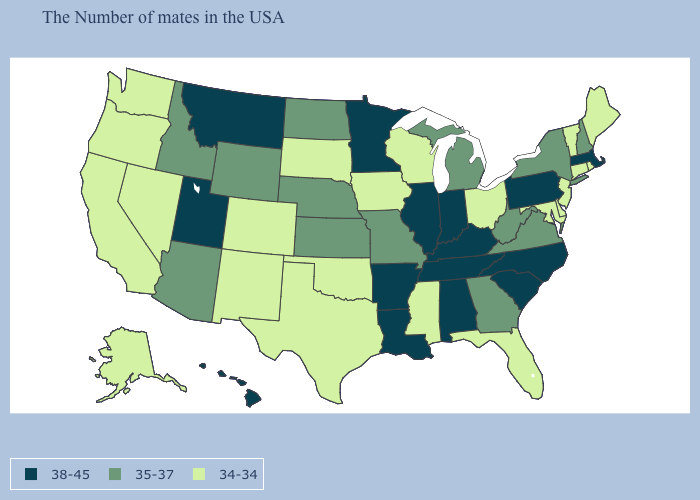Does Idaho have a higher value than New Hampshire?
Concise answer only. No. Among the states that border Louisiana , does Texas have the lowest value?
Answer briefly. Yes. Is the legend a continuous bar?
Keep it brief. No. Which states hav the highest value in the West?
Short answer required. Utah, Montana, Hawaii. Which states have the highest value in the USA?
Keep it brief. Massachusetts, Pennsylvania, North Carolina, South Carolina, Kentucky, Indiana, Alabama, Tennessee, Illinois, Louisiana, Arkansas, Minnesota, Utah, Montana, Hawaii. What is the lowest value in the USA?
Concise answer only. 34-34. What is the value of Arkansas?
Write a very short answer. 38-45. Among the states that border Texas , does Arkansas have the highest value?
Quick response, please. Yes. What is the value of Hawaii?
Keep it brief. 38-45. Does the map have missing data?
Be succinct. No. Name the states that have a value in the range 35-37?
Be succinct. New Hampshire, New York, Virginia, West Virginia, Georgia, Michigan, Missouri, Kansas, Nebraska, North Dakota, Wyoming, Arizona, Idaho. What is the lowest value in states that border Tennessee?
Quick response, please. 34-34. What is the value of Kansas?
Concise answer only. 35-37. 